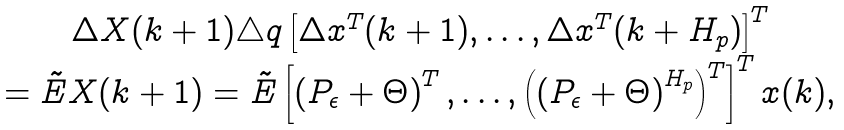Convert formula to latex. <formula><loc_0><loc_0><loc_500><loc_500>\begin{array} { c } \Delta X ( k + 1 ) \triangle q \left [ \Delta x ^ { T } ( k + 1 ) , \dots , \Delta x ^ { T } ( k + H _ { p } ) \right ] ^ { T } \\ = \tilde { E } X ( k + 1 ) = \tilde { E } \left [ \left ( P _ { \epsilon } + \Theta \right ) ^ { T } , \dots , \left ( \left ( P _ { \epsilon } + \Theta \right ) ^ { H _ { p } } \right ) ^ { T } \right ] ^ { T } x ( k ) , \end{array}</formula> 